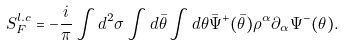<formula> <loc_0><loc_0><loc_500><loc_500>S _ { F } ^ { l . c } = - \frac { i } { \pi } \int d ^ { 2 } \sigma \int d \bar { \theta } \int d \theta \bar { \Psi } ^ { + } ( \bar { \theta } ) \rho ^ { \alpha } \partial _ { \alpha } \Psi ^ { - } ( \theta ) .</formula> 